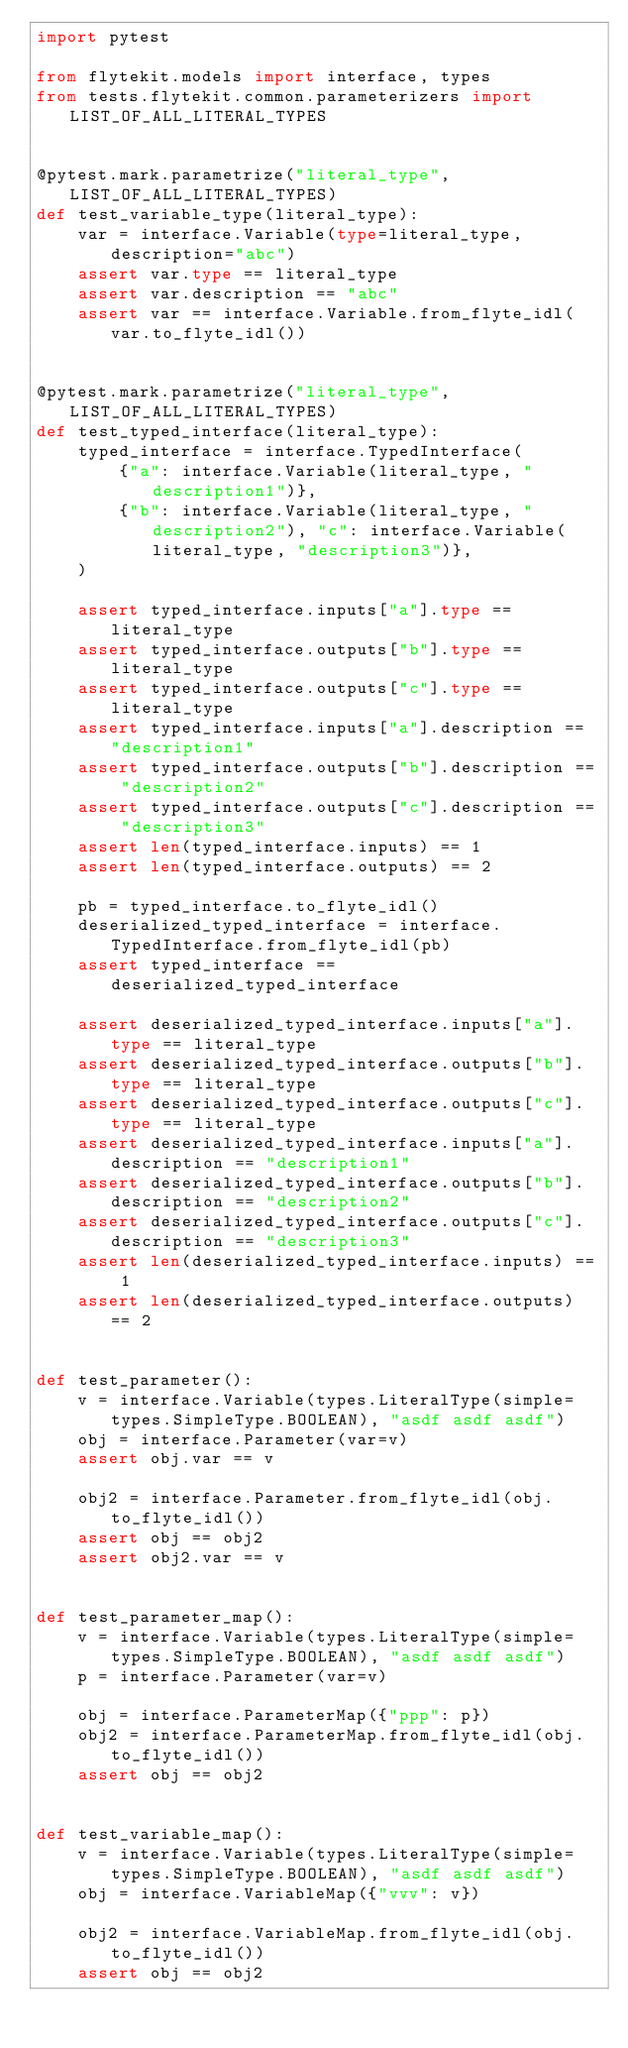Convert code to text. <code><loc_0><loc_0><loc_500><loc_500><_Python_>import pytest

from flytekit.models import interface, types
from tests.flytekit.common.parameterizers import LIST_OF_ALL_LITERAL_TYPES


@pytest.mark.parametrize("literal_type", LIST_OF_ALL_LITERAL_TYPES)
def test_variable_type(literal_type):
    var = interface.Variable(type=literal_type, description="abc")
    assert var.type == literal_type
    assert var.description == "abc"
    assert var == interface.Variable.from_flyte_idl(var.to_flyte_idl())


@pytest.mark.parametrize("literal_type", LIST_OF_ALL_LITERAL_TYPES)
def test_typed_interface(literal_type):
    typed_interface = interface.TypedInterface(
        {"a": interface.Variable(literal_type, "description1")},
        {"b": interface.Variable(literal_type, "description2"), "c": interface.Variable(literal_type, "description3")},
    )

    assert typed_interface.inputs["a"].type == literal_type
    assert typed_interface.outputs["b"].type == literal_type
    assert typed_interface.outputs["c"].type == literal_type
    assert typed_interface.inputs["a"].description == "description1"
    assert typed_interface.outputs["b"].description == "description2"
    assert typed_interface.outputs["c"].description == "description3"
    assert len(typed_interface.inputs) == 1
    assert len(typed_interface.outputs) == 2

    pb = typed_interface.to_flyte_idl()
    deserialized_typed_interface = interface.TypedInterface.from_flyte_idl(pb)
    assert typed_interface == deserialized_typed_interface

    assert deserialized_typed_interface.inputs["a"].type == literal_type
    assert deserialized_typed_interface.outputs["b"].type == literal_type
    assert deserialized_typed_interface.outputs["c"].type == literal_type
    assert deserialized_typed_interface.inputs["a"].description == "description1"
    assert deserialized_typed_interface.outputs["b"].description == "description2"
    assert deserialized_typed_interface.outputs["c"].description == "description3"
    assert len(deserialized_typed_interface.inputs) == 1
    assert len(deserialized_typed_interface.outputs) == 2


def test_parameter():
    v = interface.Variable(types.LiteralType(simple=types.SimpleType.BOOLEAN), "asdf asdf asdf")
    obj = interface.Parameter(var=v)
    assert obj.var == v

    obj2 = interface.Parameter.from_flyte_idl(obj.to_flyte_idl())
    assert obj == obj2
    assert obj2.var == v


def test_parameter_map():
    v = interface.Variable(types.LiteralType(simple=types.SimpleType.BOOLEAN), "asdf asdf asdf")
    p = interface.Parameter(var=v)

    obj = interface.ParameterMap({"ppp": p})
    obj2 = interface.ParameterMap.from_flyte_idl(obj.to_flyte_idl())
    assert obj == obj2


def test_variable_map():
    v = interface.Variable(types.LiteralType(simple=types.SimpleType.BOOLEAN), "asdf asdf asdf")
    obj = interface.VariableMap({"vvv": v})

    obj2 = interface.VariableMap.from_flyte_idl(obj.to_flyte_idl())
    assert obj == obj2
</code> 